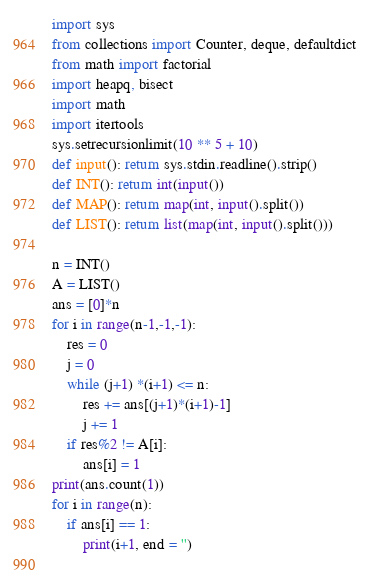Convert code to text. <code><loc_0><loc_0><loc_500><loc_500><_Python_>import sys
from collections import Counter, deque, defaultdict
from math import factorial
import heapq, bisect
import math
import itertools
sys.setrecursionlimit(10 ** 5 + 10)
def input(): return sys.stdin.readline().strip()
def INT(): return int(input())
def MAP(): return map(int, input().split())
def LIST(): return list(map(int, input().split()))

n = INT()
A = LIST()
ans = [0]*n
for i in range(n-1,-1,-1):
    res = 0
    j = 0
    while (j+1) *(i+1) <= n:
        res += ans[(j+1)*(i+1)-1]
        j += 1
    if res%2 != A[i]:
        ans[i] = 1
print(ans.count(1))
for i in range(n):
    if ans[i] == 1:
        print(i+1, end = '')
    
</code> 